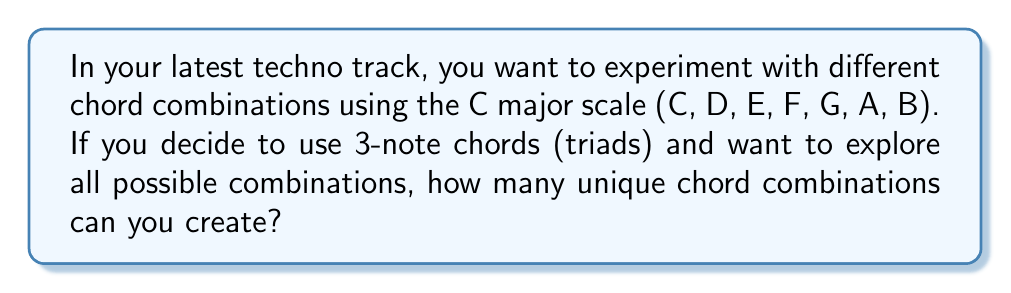What is the answer to this math problem? Let's approach this step-by-step:

1) First, we need to understand that we're dealing with combinations, not permutations, because the order of notes in a chord doesn't matter (e.g., C-E-G is the same chord as E-G-C).

2) We're selecting 3 notes out of 7 available notes in the C major scale.

3) This is a combination problem, which can be represented mathematically as:

   $$\binom{n}{r} = \frac{n!}{r!(n-r)!}$$

   Where $n$ is the total number of items to choose from, and $r$ is the number of items being chosen.

4) In this case, $n = 7$ (total notes in the scale) and $r = 3$ (notes in each chord).

5) Let's substitute these values:

   $$\binom{7}{3} = \frac{7!}{3!(7-3)!} = \frac{7!}{3!4!}$$

6) Expand this:
   
   $$\frac{7 \cdot 6 \cdot 5 \cdot 4!}{(3 \cdot 2 \cdot 1) \cdot 4!}$$

7) The $4!$ cancels out in the numerator and denominator:

   $$\frac{7 \cdot 6 \cdot 5}{3 \cdot 2 \cdot 1} = \frac{210}{6} = 35$$

Therefore, you can create 35 unique 3-note chord combinations from the C major scale.
Answer: 35 